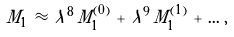<formula> <loc_0><loc_0><loc_500><loc_500>M _ { 1 } \, \approx \, \lambda ^ { 8 } \, M _ { 1 } ^ { ( 0 ) } \, + \, \lambda ^ { 9 } \, M _ { 1 } ^ { ( 1 ) } \, + \, \dots \, , \,</formula> 